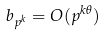Convert formula to latex. <formula><loc_0><loc_0><loc_500><loc_500>b _ { p ^ { k } } = O ( p ^ { k \theta } )</formula> 